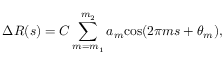Convert formula to latex. <formula><loc_0><loc_0><loc_500><loc_500>\Delta R ( s ) = C \sum _ { m = m _ { 1 } } ^ { m _ { 2 } } a _ { m } \cos ( 2 \pi m s + \theta _ { m } ) ,</formula> 